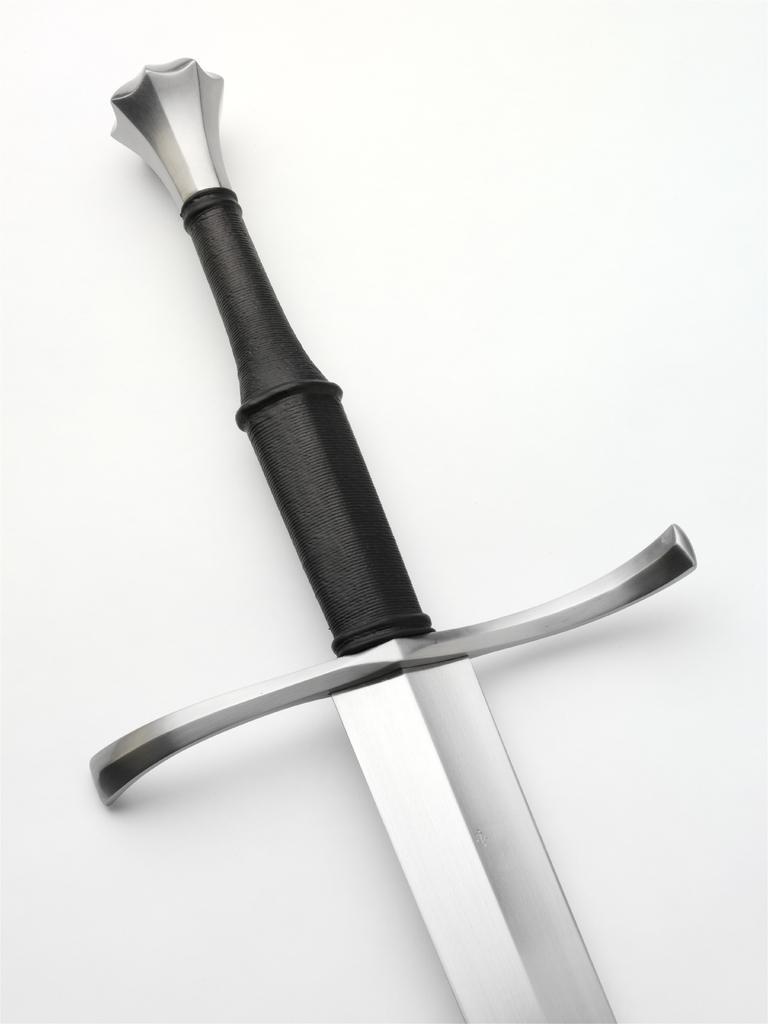In one or two sentences, can you explain what this image depicts? In this image, we can see a sword on the white surface. 